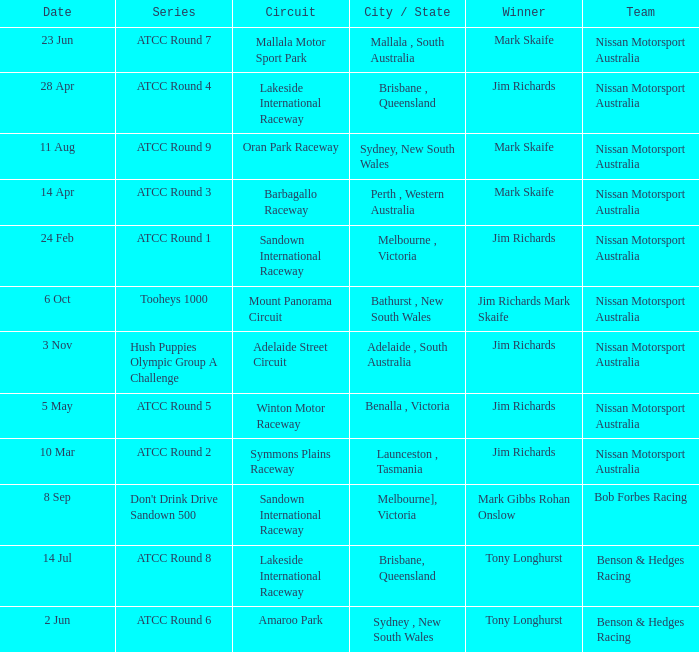What is the Team of Winner Mark Skaife in ATCC Round 7? Nissan Motorsport Australia. 